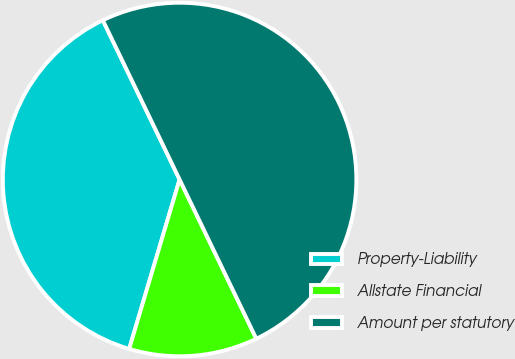<chart> <loc_0><loc_0><loc_500><loc_500><pie_chart><fcel>Property-Liability<fcel>Allstate Financial<fcel>Amount per statutory<nl><fcel>38.25%<fcel>11.75%<fcel>50.0%<nl></chart> 